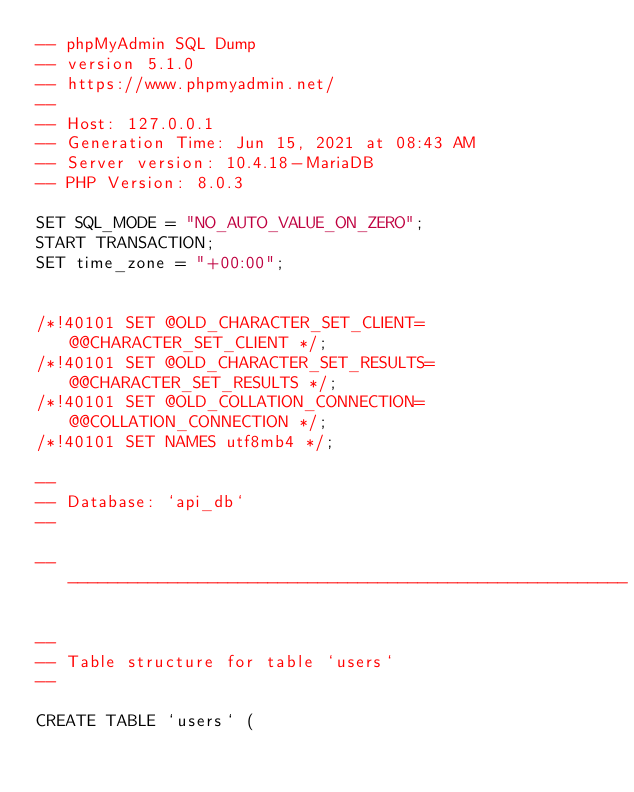<code> <loc_0><loc_0><loc_500><loc_500><_SQL_>-- phpMyAdmin SQL Dump
-- version 5.1.0
-- https://www.phpmyadmin.net/
--
-- Host: 127.0.0.1
-- Generation Time: Jun 15, 2021 at 08:43 AM
-- Server version: 10.4.18-MariaDB
-- PHP Version: 8.0.3

SET SQL_MODE = "NO_AUTO_VALUE_ON_ZERO";
START TRANSACTION;
SET time_zone = "+00:00";


/*!40101 SET @OLD_CHARACTER_SET_CLIENT=@@CHARACTER_SET_CLIENT */;
/*!40101 SET @OLD_CHARACTER_SET_RESULTS=@@CHARACTER_SET_RESULTS */;
/*!40101 SET @OLD_COLLATION_CONNECTION=@@COLLATION_CONNECTION */;
/*!40101 SET NAMES utf8mb4 */;

--
-- Database: `api_db`
--

-- --------------------------------------------------------

--
-- Table structure for table `users`
--

CREATE TABLE `users` (</code> 